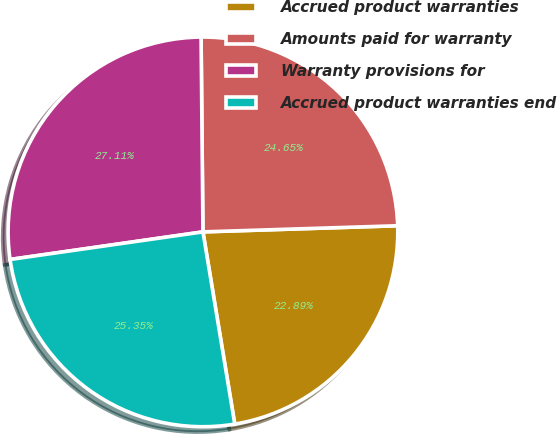Convert chart. <chart><loc_0><loc_0><loc_500><loc_500><pie_chart><fcel>Accrued product warranties<fcel>Amounts paid for warranty<fcel>Warranty provisions for<fcel>Accrued product warranties end<nl><fcel>22.89%<fcel>24.65%<fcel>27.11%<fcel>25.35%<nl></chart> 